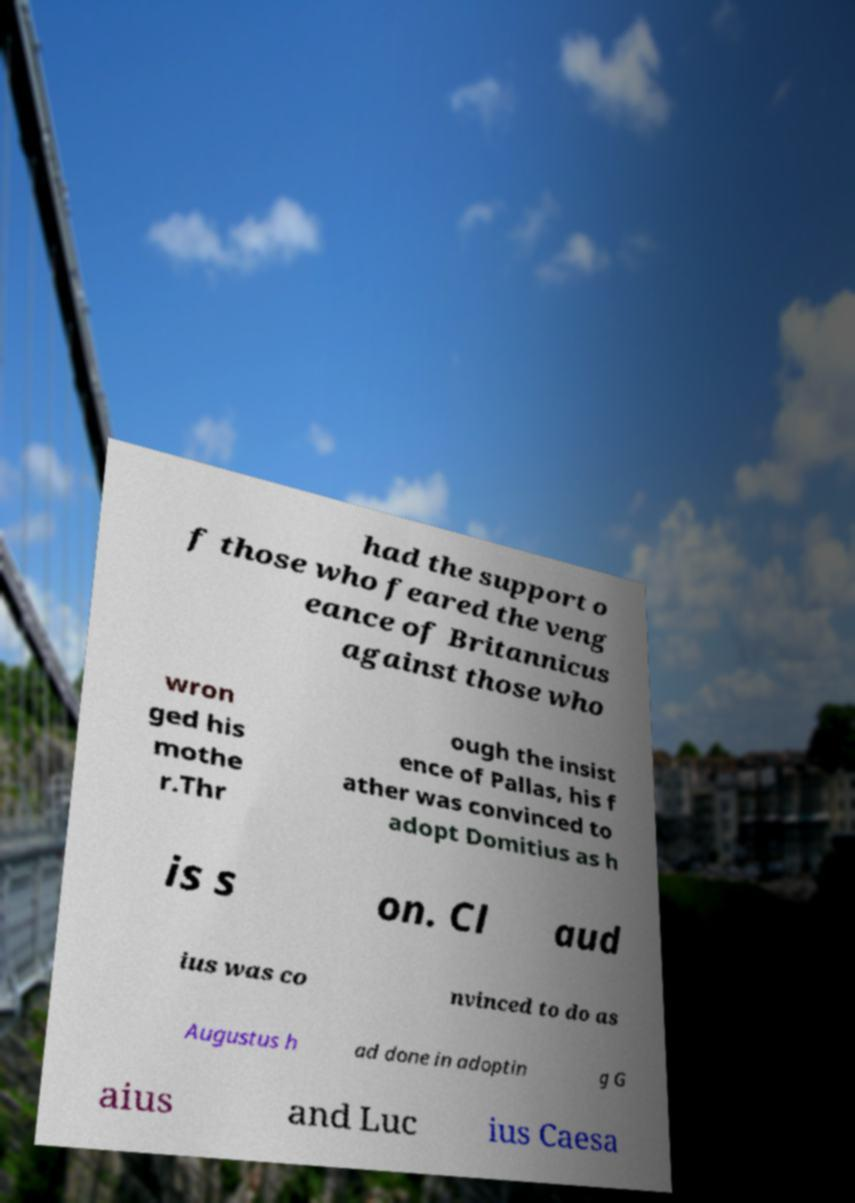Can you read and provide the text displayed in the image?This photo seems to have some interesting text. Can you extract and type it out for me? had the support o f those who feared the veng eance of Britannicus against those who wron ged his mothe r.Thr ough the insist ence of Pallas, his f ather was convinced to adopt Domitius as h is s on. Cl aud ius was co nvinced to do as Augustus h ad done in adoptin g G aius and Luc ius Caesa 